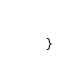<code> <loc_0><loc_0><loc_500><loc_500><_Scala_>}</code> 